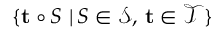Convert formula to latex. <formula><loc_0><loc_0><loc_500><loc_500>\{ \mathbf t \circ S \, | \, S \in \mathcal { S } , \, \mathbf t \in \mathcal { T } \}</formula> 